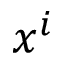<formula> <loc_0><loc_0><loc_500><loc_500>x ^ { i }</formula> 